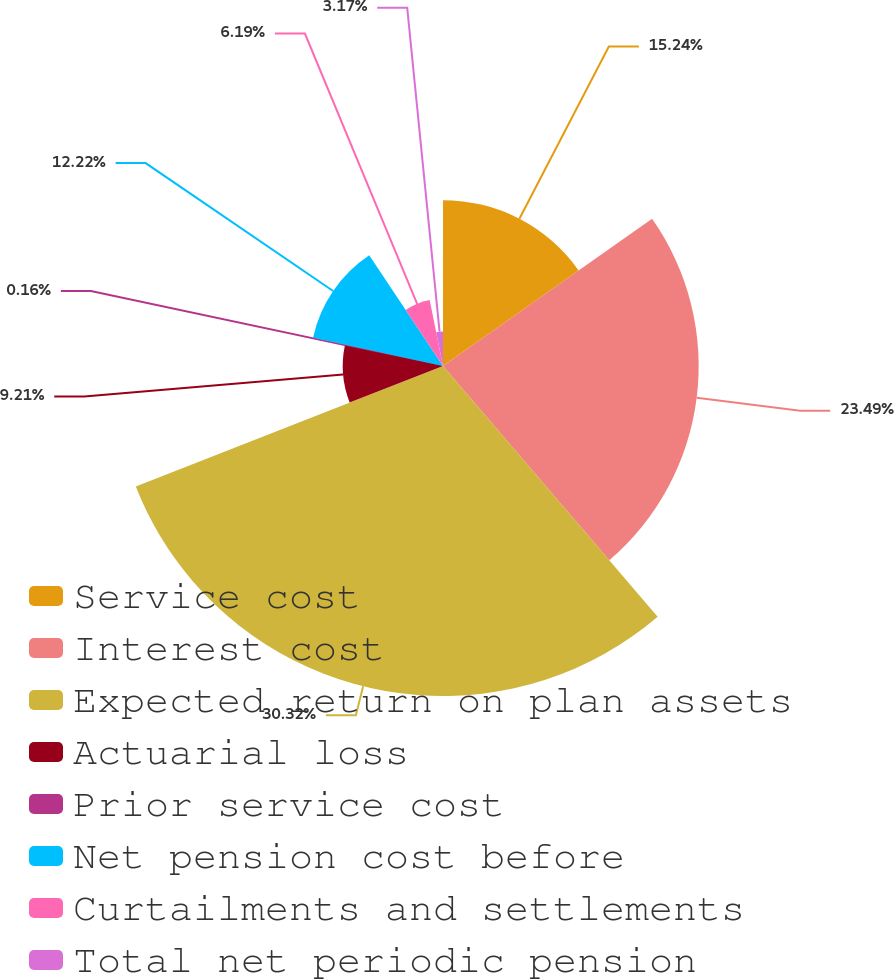Convert chart to OTSL. <chart><loc_0><loc_0><loc_500><loc_500><pie_chart><fcel>Service cost<fcel>Interest cost<fcel>Expected return on plan assets<fcel>Actuarial loss<fcel>Prior service cost<fcel>Net pension cost before<fcel>Curtailments and settlements<fcel>Total net periodic pension<nl><fcel>15.24%<fcel>23.49%<fcel>30.32%<fcel>9.21%<fcel>0.16%<fcel>12.22%<fcel>6.19%<fcel>3.17%<nl></chart> 